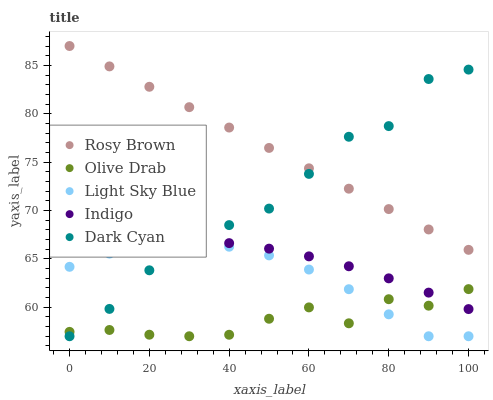Does Olive Drab have the minimum area under the curve?
Answer yes or no. Yes. Does Rosy Brown have the maximum area under the curve?
Answer yes or no. Yes. Does Indigo have the minimum area under the curve?
Answer yes or no. No. Does Indigo have the maximum area under the curve?
Answer yes or no. No. Is Rosy Brown the smoothest?
Answer yes or no. Yes. Is Dark Cyan the roughest?
Answer yes or no. Yes. Is Indigo the smoothest?
Answer yes or no. No. Is Indigo the roughest?
Answer yes or no. No. Does Dark Cyan have the lowest value?
Answer yes or no. Yes. Does Indigo have the lowest value?
Answer yes or no. No. Does Rosy Brown have the highest value?
Answer yes or no. Yes. Does Indigo have the highest value?
Answer yes or no. No. Is Indigo less than Rosy Brown?
Answer yes or no. Yes. Is Rosy Brown greater than Indigo?
Answer yes or no. Yes. Does Dark Cyan intersect Rosy Brown?
Answer yes or no. Yes. Is Dark Cyan less than Rosy Brown?
Answer yes or no. No. Is Dark Cyan greater than Rosy Brown?
Answer yes or no. No. Does Indigo intersect Rosy Brown?
Answer yes or no. No. 